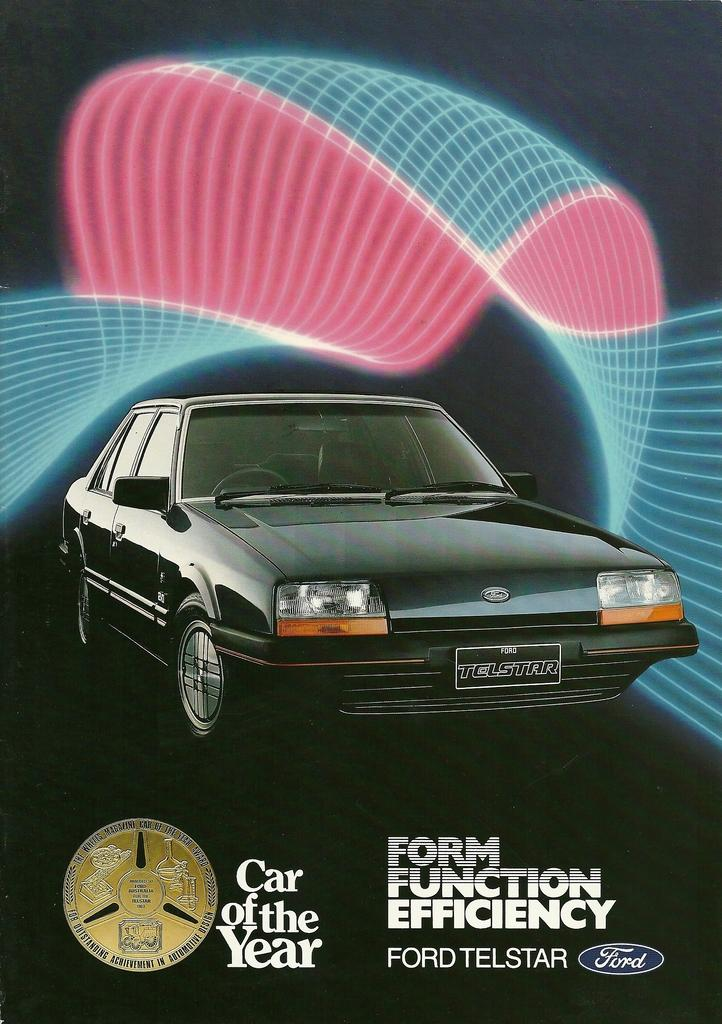What is the main subject of the image? The main subject of the image is a car. Can you describe the car's appearance? The car is black in color and has headlights. Is there any identifying information on the car? Yes, the car has a number plate. What else can be seen in the image besides the car? There is a text element and a light effect in the image. What type of punishment is the queen imposing on the car in the image? There is no queen or punishment present in the image; it features a car with a number plate and other elements. Is there a lock on the car in the image? No, there is no lock visible on the car in the image. 